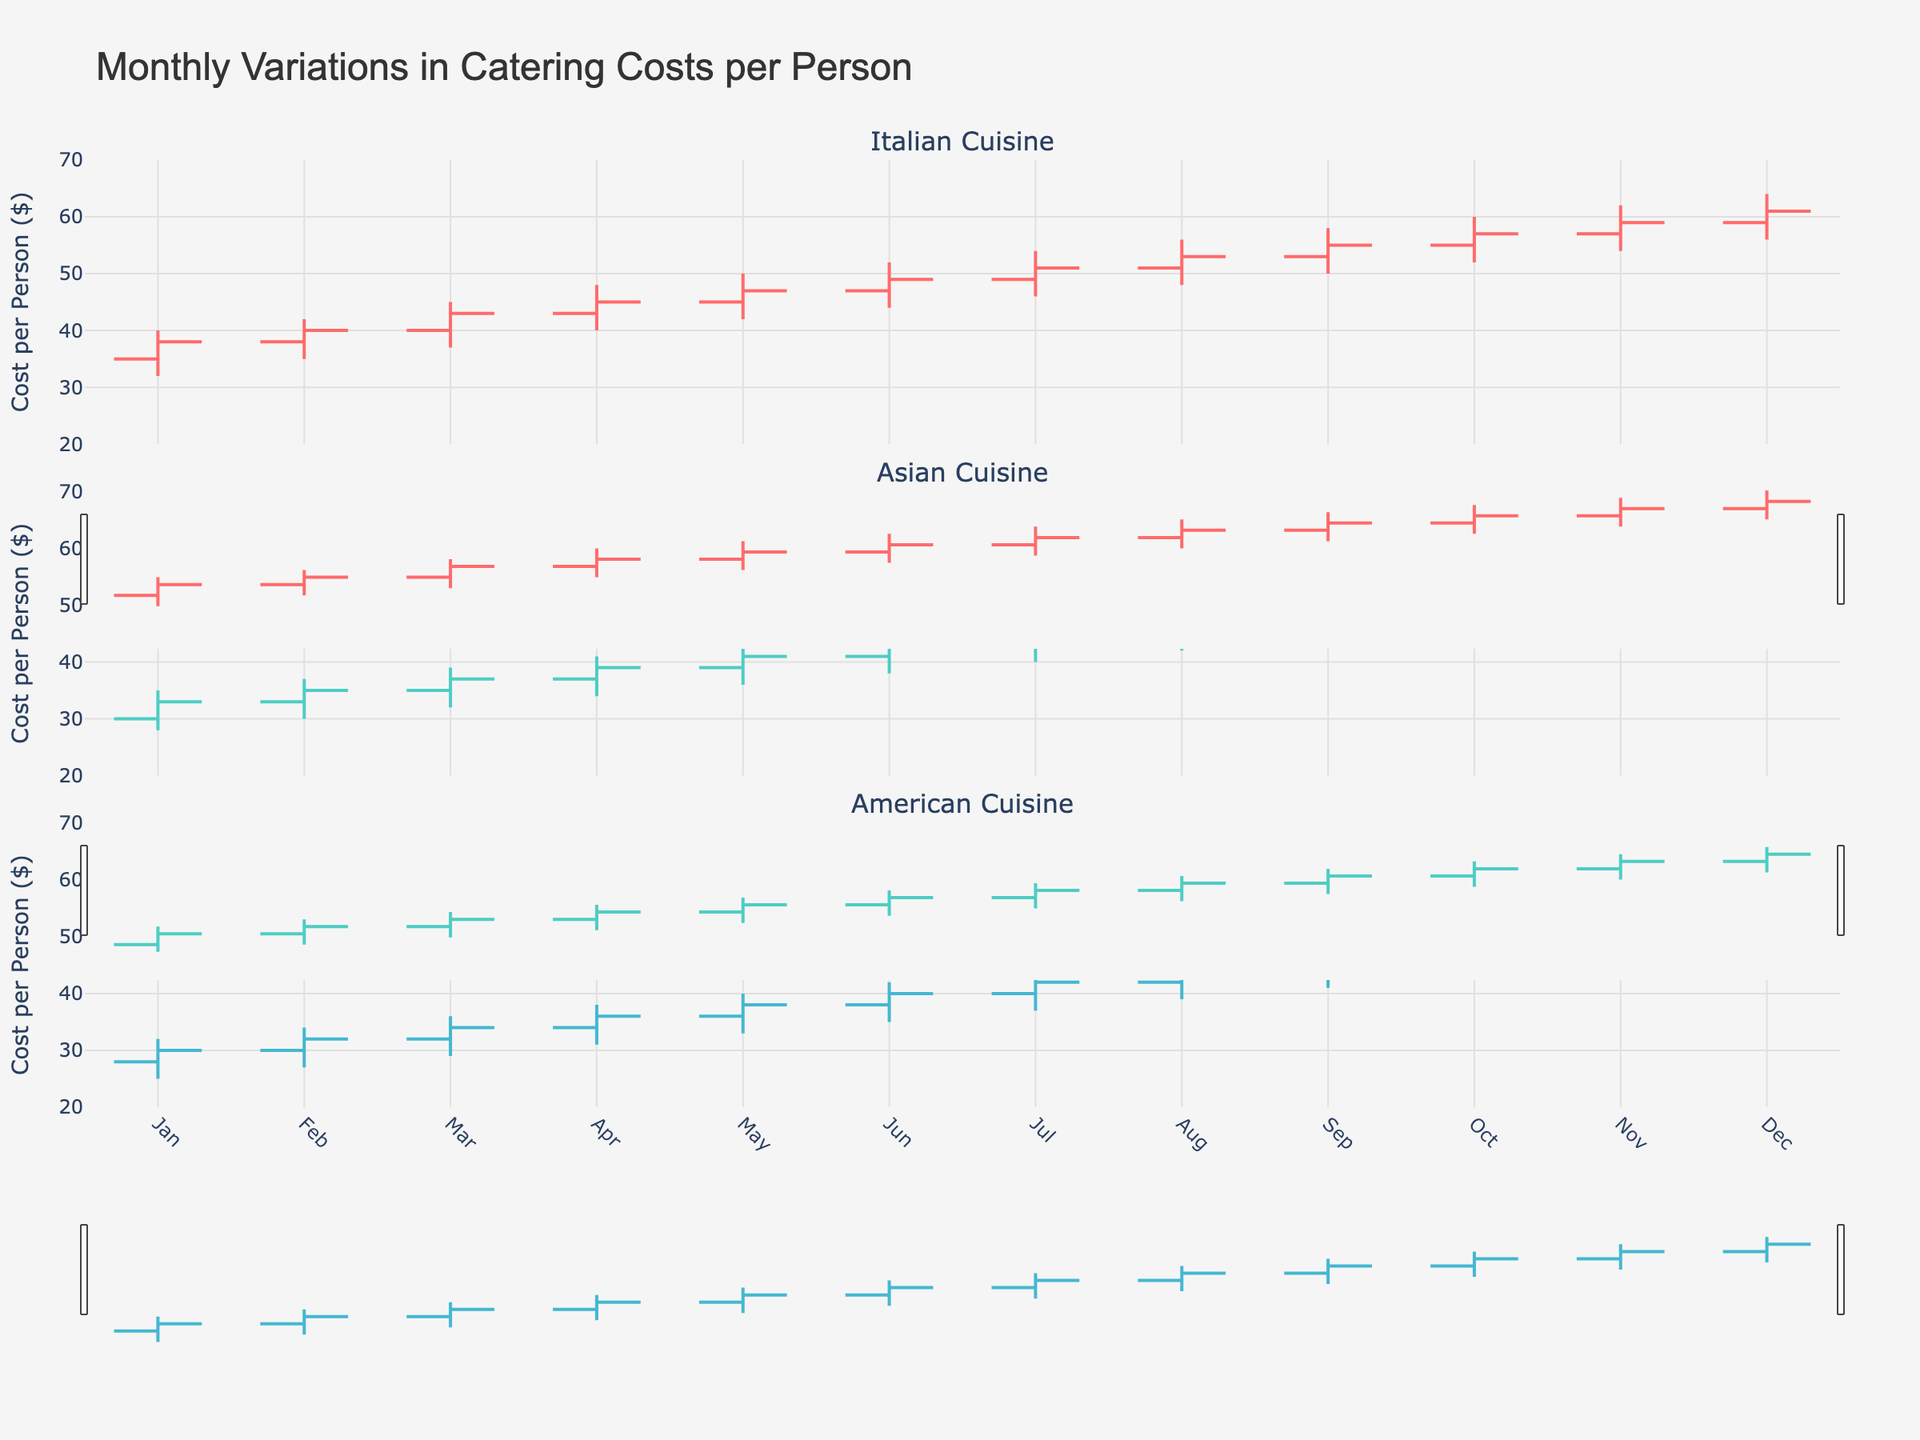What's the title of the figure? The title is displayed at the top of the figure, providing an overview of what the chart is about. The title is "Monthly Variations in Catering Costs per Person".
Answer: Monthly Variations in Catering Costs per Person What is the cost range for Italian cuisine in May? Examine the OHLC data for May regarding the Italian cuisine. The low value is $42 and the high value is $50.
Answer: $42 to $50 Which cuisine had the highest cost per person in December and what was the closing cost? Compare the closing costs in December for each cuisine. Italian closes at $61, Asian at $55, and American at $52. Italian cuisine had the highest closing cost in December.
Answer: Italian, $61 In which month did American cuisine have the lowest catering cost per person and what was the value? Review the low values for American cuisine over the months. The lowest value is $25 in January.
Answer: January, $25 What is the overall trend in the cost per person for Italian cuisine from January to December? Analyze the closing costs for Italian cuisine from January ($38) to December ($61). Observe an increasing trend month to month.
Answer: Increasing trend How much did the cost per person for Asian cuisine increase from January to December based on closing costs? Calculate the difference between the closing cost in December ($55) and the closing cost in January ($33). The difference is $55 - $33 = $22.
Answer: $22 Between June and July, which cuisine shows the most significant increase in closing costs per person? Compare the change in closing costs from June to July for each cuisine. Italian increased by $2 ($49 to $51), Asian by $2 ($43 to $45), and American by $2 ($40 to $42). All cuisines had the same increase.
Answer: All cuisines, $2 Which month had the highest variability in costs for Asian cuisine and what were the highest and lowest values? Examine the high and low values for Asian cuisine across all months. In October, the value range is the widest with a low of $46 and a high of $53.
Answer: October, $46 to $53 Did American cuisine ever exceed $50 in cost per person for closing in any month? Review the closing values for American cuisine. It closes at $50 or more in November ($50) and December ($52).
Answer: Yes, in November and December 